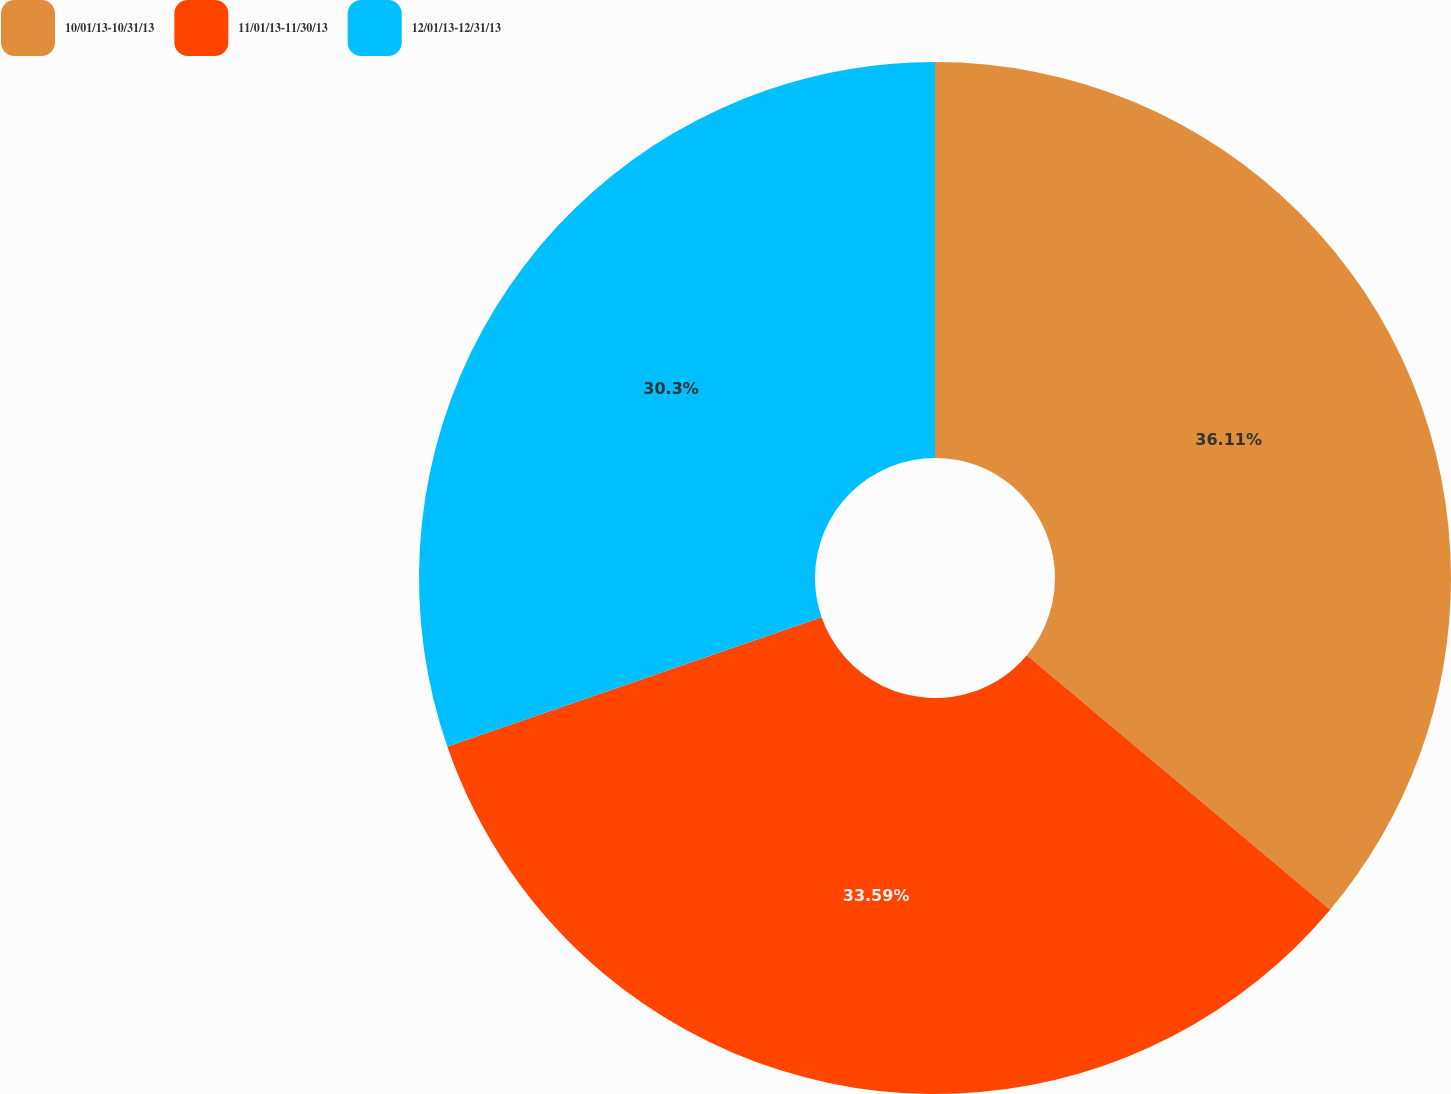Convert chart. <chart><loc_0><loc_0><loc_500><loc_500><pie_chart><fcel>10/01/13-10/31/13<fcel>11/01/13-11/30/13<fcel>12/01/13-12/31/13<nl><fcel>36.12%<fcel>33.59%<fcel>30.3%<nl></chart> 